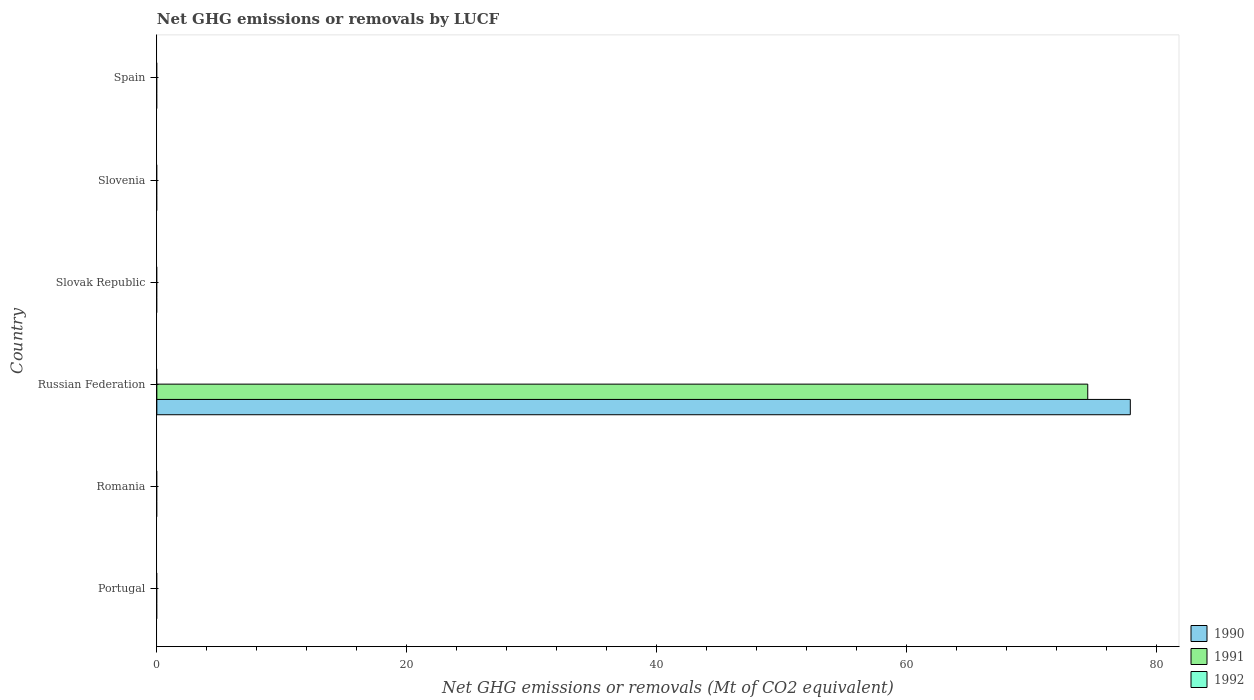How many different coloured bars are there?
Your answer should be very brief. 2. Are the number of bars per tick equal to the number of legend labels?
Give a very brief answer. No. Are the number of bars on each tick of the Y-axis equal?
Offer a very short reply. No. How many bars are there on the 5th tick from the top?
Provide a short and direct response. 0. What is the label of the 3rd group of bars from the top?
Provide a short and direct response. Slovak Republic. In how many cases, is the number of bars for a given country not equal to the number of legend labels?
Offer a terse response. 6. Across all countries, what is the maximum net GHG emissions or removals by LUCF in 1990?
Provide a short and direct response. 77.88. In which country was the net GHG emissions or removals by LUCF in 1990 maximum?
Your response must be concise. Russian Federation. What is the total net GHG emissions or removals by LUCF in 1990 in the graph?
Offer a very short reply. 77.88. What is the difference between the net GHG emissions or removals by LUCF in 1990 in Russian Federation and the net GHG emissions or removals by LUCF in 1991 in Portugal?
Your answer should be compact. 77.88. What is the difference between the highest and the lowest net GHG emissions or removals by LUCF in 1991?
Your answer should be very brief. 74.48. In how many countries, is the net GHG emissions or removals by LUCF in 1992 greater than the average net GHG emissions or removals by LUCF in 1992 taken over all countries?
Provide a succinct answer. 0. How many bars are there?
Your answer should be compact. 2. Are all the bars in the graph horizontal?
Make the answer very short. Yes. How are the legend labels stacked?
Give a very brief answer. Vertical. What is the title of the graph?
Your answer should be very brief. Net GHG emissions or removals by LUCF. What is the label or title of the X-axis?
Keep it short and to the point. Net GHG emissions or removals (Mt of CO2 equivalent). What is the Net GHG emissions or removals (Mt of CO2 equivalent) of 1991 in Portugal?
Provide a short and direct response. 0. What is the Net GHG emissions or removals (Mt of CO2 equivalent) in 1990 in Romania?
Give a very brief answer. 0. What is the Net GHG emissions or removals (Mt of CO2 equivalent) in 1991 in Romania?
Provide a short and direct response. 0. What is the Net GHG emissions or removals (Mt of CO2 equivalent) in 1992 in Romania?
Offer a terse response. 0. What is the Net GHG emissions or removals (Mt of CO2 equivalent) of 1990 in Russian Federation?
Your answer should be very brief. 77.88. What is the Net GHG emissions or removals (Mt of CO2 equivalent) in 1991 in Russian Federation?
Give a very brief answer. 74.48. What is the Net GHG emissions or removals (Mt of CO2 equivalent) of 1990 in Slovenia?
Your answer should be very brief. 0. What is the Net GHG emissions or removals (Mt of CO2 equivalent) of 1991 in Slovenia?
Give a very brief answer. 0. What is the Net GHG emissions or removals (Mt of CO2 equivalent) in 1991 in Spain?
Provide a short and direct response. 0. What is the Net GHG emissions or removals (Mt of CO2 equivalent) in 1992 in Spain?
Your answer should be very brief. 0. Across all countries, what is the maximum Net GHG emissions or removals (Mt of CO2 equivalent) in 1990?
Make the answer very short. 77.88. Across all countries, what is the maximum Net GHG emissions or removals (Mt of CO2 equivalent) in 1991?
Provide a short and direct response. 74.48. Across all countries, what is the minimum Net GHG emissions or removals (Mt of CO2 equivalent) of 1991?
Provide a short and direct response. 0. What is the total Net GHG emissions or removals (Mt of CO2 equivalent) of 1990 in the graph?
Make the answer very short. 77.89. What is the total Net GHG emissions or removals (Mt of CO2 equivalent) of 1991 in the graph?
Your answer should be compact. 74.48. What is the total Net GHG emissions or removals (Mt of CO2 equivalent) of 1992 in the graph?
Your answer should be compact. 0. What is the average Net GHG emissions or removals (Mt of CO2 equivalent) of 1990 per country?
Your response must be concise. 12.98. What is the average Net GHG emissions or removals (Mt of CO2 equivalent) in 1991 per country?
Make the answer very short. 12.41. What is the average Net GHG emissions or removals (Mt of CO2 equivalent) in 1992 per country?
Provide a succinct answer. 0. What is the difference between the Net GHG emissions or removals (Mt of CO2 equivalent) of 1990 and Net GHG emissions or removals (Mt of CO2 equivalent) of 1991 in Russian Federation?
Give a very brief answer. 3.41. What is the difference between the highest and the lowest Net GHG emissions or removals (Mt of CO2 equivalent) of 1990?
Your answer should be compact. 77.89. What is the difference between the highest and the lowest Net GHG emissions or removals (Mt of CO2 equivalent) of 1991?
Make the answer very short. 74.48. 